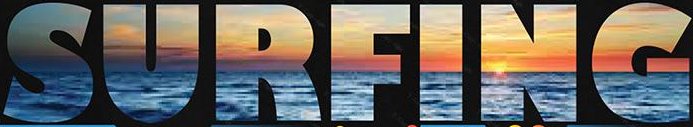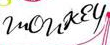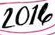Transcribe the words shown in these images in order, separated by a semicolon. SURFING; monkey; 2014 